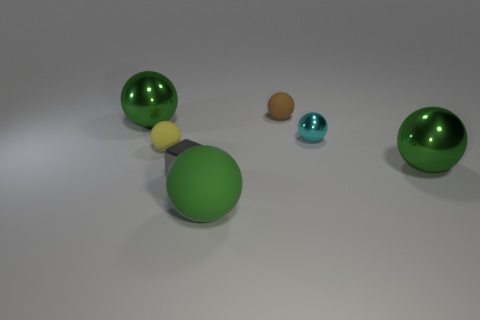Subtract all yellow blocks. How many green spheres are left? 3 Subtract all tiny metallic spheres. How many spheres are left? 5 Subtract all yellow spheres. How many spheres are left? 5 Subtract all brown spheres. Subtract all yellow cubes. How many spheres are left? 5 Add 3 small cyan objects. How many objects exist? 10 Subtract all cubes. How many objects are left? 6 Add 5 brown matte balls. How many brown matte balls exist? 6 Subtract 0 purple cylinders. How many objects are left? 7 Subtract all yellow rubber balls. Subtract all small brown spheres. How many objects are left? 5 Add 2 big shiny things. How many big shiny things are left? 4 